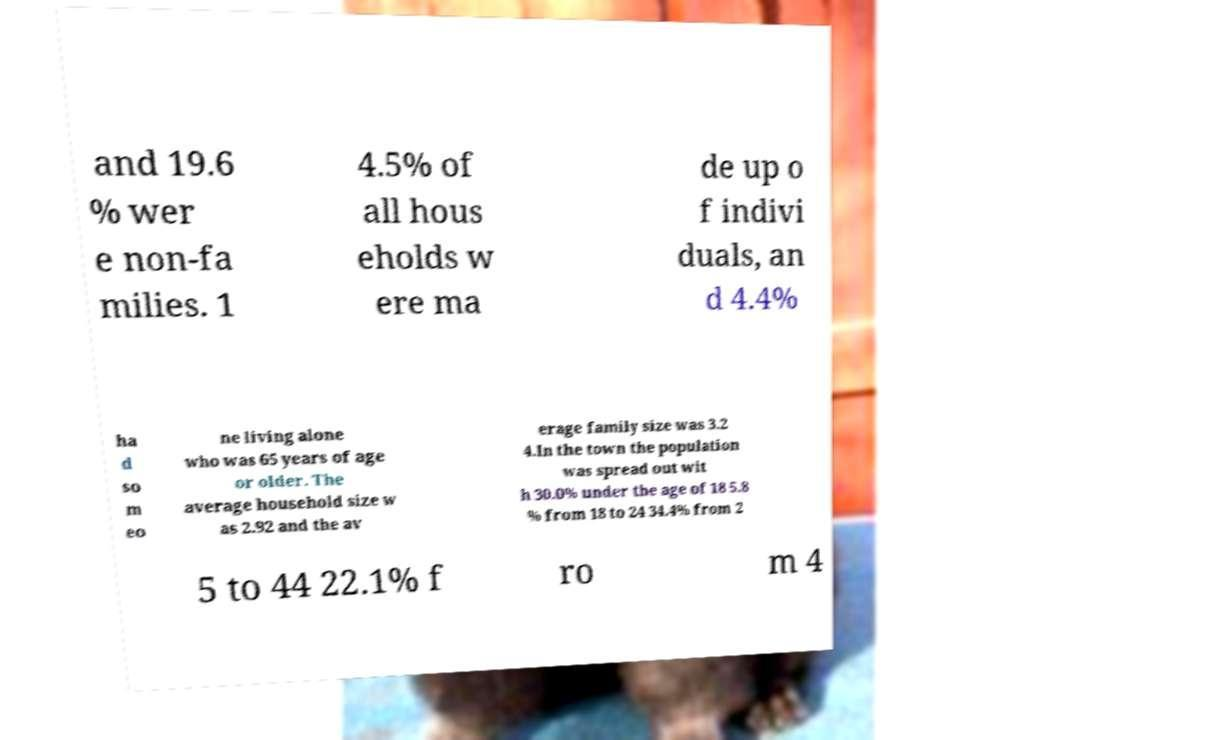Could you assist in decoding the text presented in this image and type it out clearly? and 19.6 % wer e non-fa milies. 1 4.5% of all hous eholds w ere ma de up o f indivi duals, an d 4.4% ha d so m eo ne living alone who was 65 years of age or older. The average household size w as 2.92 and the av erage family size was 3.2 4.In the town the population was spread out wit h 30.0% under the age of 18 5.8 % from 18 to 24 34.4% from 2 5 to 44 22.1% f ro m 4 